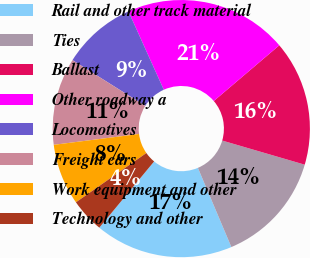Convert chart to OTSL. <chart><loc_0><loc_0><loc_500><loc_500><pie_chart><fcel>Rail and other track material<fcel>Ties<fcel>Ballast<fcel>Other roadway a<fcel>Locomotives<fcel>Freight cars<fcel>Work equipment and other<fcel>Technology and other<nl><fcel>17.37%<fcel>14.11%<fcel>15.74%<fcel>20.53%<fcel>9.32%<fcel>10.95%<fcel>7.7%<fcel>4.28%<nl></chart> 